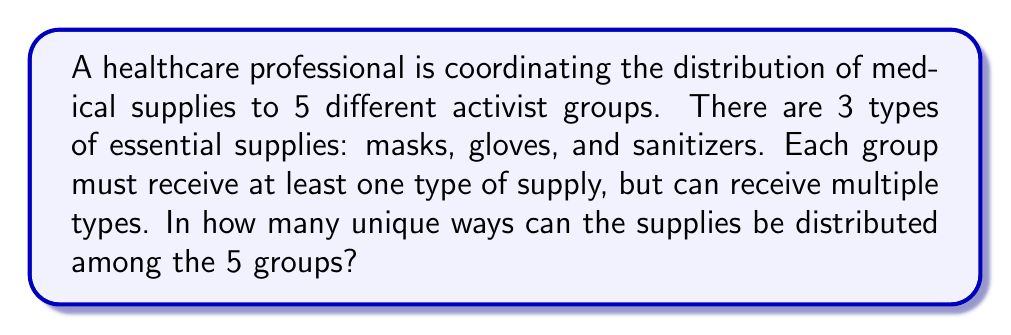Can you solve this math problem? Let's approach this step-by-step:

1) This is a problem of distributing distinct objects (types of supplies) into distinct boxes (activist groups).

2) For each type of supply, we have two choices for each group: give it to the group or not.

3) This means for each supply type, we have $2^5 = 32$ choices (as there are 5 groups).

4) However, we can't have a situation where no group receives a particular supply. So we need to subtract 1 from each 32 (the case where no group gets that supply).

5) Thus, for each supply type, we have 31 valid distribution options.

6) Since we have 3 types of supplies, and each can be distributed independently, we multiply these options:

   $$(2^5 - 1)^3 = 31^3 = 29,791$$

7) However, this includes the case where some groups might not receive any supplies at all, which violates our condition that each group must receive at least one type of supply.

8) To exclude these cases, we can use the Inclusion-Exclusion Principle:

   Let $A_i$ be the number of distributions where group $i$ receives no supplies.

   $|A_i| = 2^{3\cdot4} = 4,096$ (as the other 4 groups can receive any combination of the 3 supplies)

   There are $\binom{5}{1} = 5$ such sets.

   $|A_i \cap A_j| = 2^{3\cdot3} = 512$ (distributions where 2 specific groups get no supplies)

   There are $\binom{5}{2} = 10$ such intersections.

   $|A_i \cap A_j \cap A_k| = 2^{3\cdot2} = 64$ (distributions where 3 specific groups get no supplies)

   There are $\binom{5}{3} = 10$ such intersections.

   $|A_i \cap A_j \cap A_k \cap A_l| = 2^{3\cdot1} = 8$ (distributions where 4 specific groups get no supplies)

   There are $\binom{5}{4} = 5$ such intersections.

   $|A_1 \cap A_2 \cap A_3 \cap A_4 \cap A_5| = 0$ (as at least one group must get supplies)

9) Applying the Inclusion-Exclusion Principle:

   $$29,791 - (5 \cdot 4,096) + (10 \cdot 512) - (10 \cdot 64) + (5 \cdot 8) - 0 = 29,791 - 20,480 + 5,120 - 640 + 40 = 13,831$$

Therefore, there are 13,831 unique ways to distribute the supplies.
Answer: 13,831 